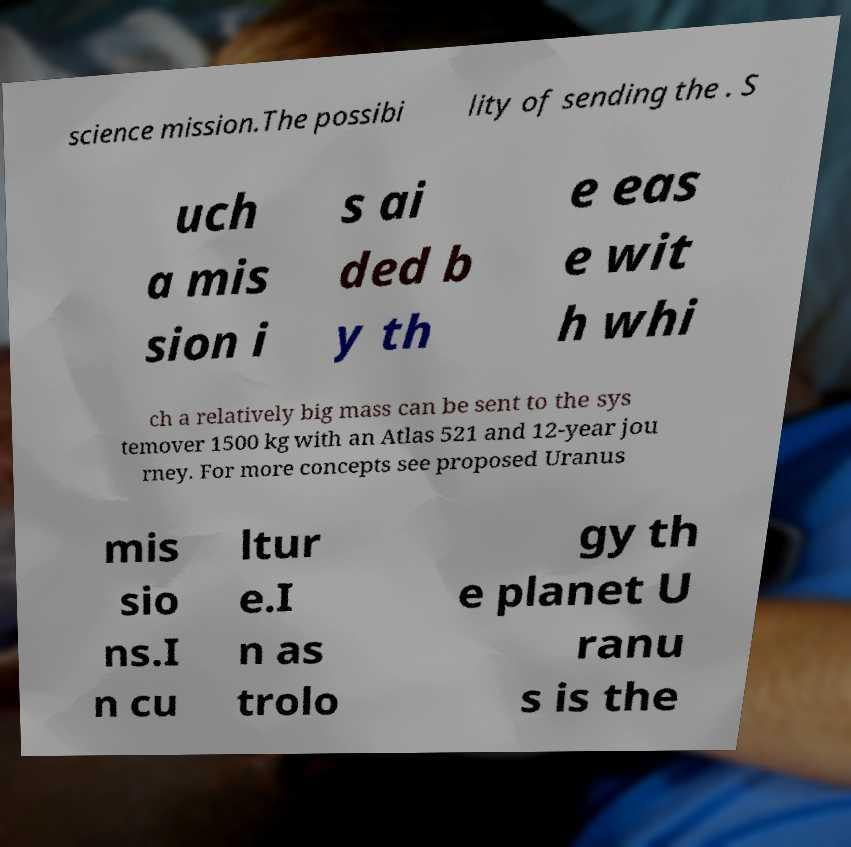For documentation purposes, I need the text within this image transcribed. Could you provide that? science mission.The possibi lity of sending the . S uch a mis sion i s ai ded b y th e eas e wit h whi ch a relatively big mass can be sent to the sys temover 1500 kg with an Atlas 521 and 12-year jou rney. For more concepts see proposed Uranus mis sio ns.I n cu ltur e.I n as trolo gy th e planet U ranu s is the 